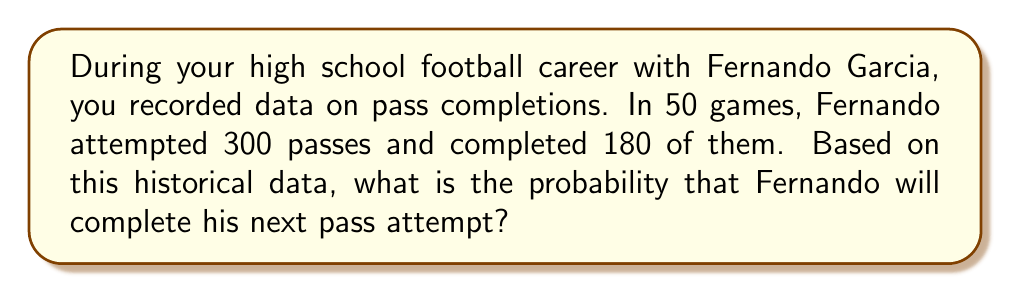Can you solve this math problem? To find the probability of Fernando completing his next pass based on historical data, we need to follow these steps:

1. Identify the total number of pass attempts:
   $n_{total} = 300$

2. Identify the number of successful pass completions:
   $n_{completed} = 180$

3. Calculate the probability of completing a pass using the formula:
   $$P(\text{completion}) = \frac{\text{number of successful outcomes}}{\text{total number of possible outcomes}}$$

4. Substitute the values:
   $$P(\text{completion}) = \frac{n_{completed}}{n_{total}} = \frac{180}{300}$$

5. Simplify the fraction:
   $$P(\text{completion}) = \frac{180}{300} = \frac{3}{5} = 0.6$$

Therefore, based on the historical data from your high school football career with Fernando Garcia, the probability that he will complete his next pass attempt is 0.6 or 60%.
Answer: $\frac{3}{5}$ or 0.6 